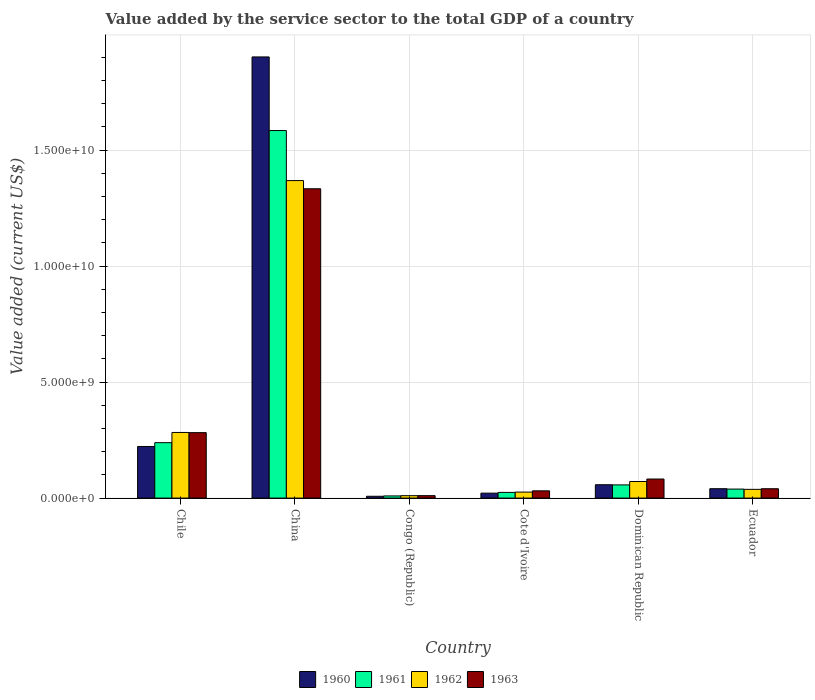How many different coloured bars are there?
Your answer should be very brief. 4. Are the number of bars per tick equal to the number of legend labels?
Offer a very short reply. Yes. How many bars are there on the 4th tick from the left?
Ensure brevity in your answer.  4. What is the label of the 5th group of bars from the left?
Keep it short and to the point. Dominican Republic. What is the value added by the service sector to the total GDP in 1960 in Chile?
Make the answer very short. 2.22e+09. Across all countries, what is the maximum value added by the service sector to the total GDP in 1963?
Make the answer very short. 1.33e+1. Across all countries, what is the minimum value added by the service sector to the total GDP in 1962?
Ensure brevity in your answer.  1.04e+08. In which country was the value added by the service sector to the total GDP in 1960 minimum?
Keep it short and to the point. Congo (Republic). What is the total value added by the service sector to the total GDP in 1961 in the graph?
Keep it short and to the point. 1.95e+1. What is the difference between the value added by the service sector to the total GDP in 1960 in Chile and that in Cote d'Ivoire?
Offer a very short reply. 2.01e+09. What is the difference between the value added by the service sector to the total GDP in 1962 in Chile and the value added by the service sector to the total GDP in 1960 in Dominican Republic?
Keep it short and to the point. 2.25e+09. What is the average value added by the service sector to the total GDP in 1963 per country?
Make the answer very short. 2.97e+09. What is the difference between the value added by the service sector to the total GDP of/in 1961 and value added by the service sector to the total GDP of/in 1963 in China?
Your response must be concise. 2.51e+09. In how many countries, is the value added by the service sector to the total GDP in 1961 greater than 11000000000 US$?
Provide a succinct answer. 1. What is the ratio of the value added by the service sector to the total GDP in 1961 in Cote d'Ivoire to that in Ecuador?
Make the answer very short. 0.63. Is the difference between the value added by the service sector to the total GDP in 1961 in Dominican Republic and Ecuador greater than the difference between the value added by the service sector to the total GDP in 1963 in Dominican Republic and Ecuador?
Your answer should be very brief. No. What is the difference between the highest and the second highest value added by the service sector to the total GDP in 1961?
Keep it short and to the point. 1.82e+09. What is the difference between the highest and the lowest value added by the service sector to the total GDP in 1963?
Keep it short and to the point. 1.32e+1. In how many countries, is the value added by the service sector to the total GDP in 1960 greater than the average value added by the service sector to the total GDP in 1960 taken over all countries?
Provide a short and direct response. 1. Is the sum of the value added by the service sector to the total GDP in 1963 in China and Cote d'Ivoire greater than the maximum value added by the service sector to the total GDP in 1960 across all countries?
Offer a very short reply. No. Is it the case that in every country, the sum of the value added by the service sector to the total GDP in 1962 and value added by the service sector to the total GDP in 1963 is greater than the sum of value added by the service sector to the total GDP in 1960 and value added by the service sector to the total GDP in 1961?
Offer a very short reply. No. How many bars are there?
Give a very brief answer. 24. What is the difference between two consecutive major ticks on the Y-axis?
Make the answer very short. 5.00e+09. Are the values on the major ticks of Y-axis written in scientific E-notation?
Keep it short and to the point. Yes. Does the graph contain any zero values?
Provide a short and direct response. No. Does the graph contain grids?
Provide a short and direct response. Yes. Where does the legend appear in the graph?
Give a very brief answer. Bottom center. How many legend labels are there?
Ensure brevity in your answer.  4. How are the legend labels stacked?
Provide a succinct answer. Horizontal. What is the title of the graph?
Your response must be concise. Value added by the service sector to the total GDP of a country. What is the label or title of the Y-axis?
Give a very brief answer. Value added (current US$). What is the Value added (current US$) of 1960 in Chile?
Ensure brevity in your answer.  2.22e+09. What is the Value added (current US$) of 1961 in Chile?
Provide a succinct answer. 2.39e+09. What is the Value added (current US$) of 1962 in Chile?
Provide a short and direct response. 2.83e+09. What is the Value added (current US$) in 1963 in Chile?
Provide a short and direct response. 2.82e+09. What is the Value added (current US$) of 1960 in China?
Provide a succinct answer. 1.90e+1. What is the Value added (current US$) of 1961 in China?
Make the answer very short. 1.58e+1. What is the Value added (current US$) of 1962 in China?
Your response must be concise. 1.37e+1. What is the Value added (current US$) in 1963 in China?
Provide a short and direct response. 1.33e+1. What is the Value added (current US$) in 1960 in Congo (Republic)?
Offer a very short reply. 7.82e+07. What is the Value added (current US$) in 1961 in Congo (Republic)?
Your answer should be compact. 9.33e+07. What is the Value added (current US$) of 1962 in Congo (Republic)?
Offer a very short reply. 1.04e+08. What is the Value added (current US$) of 1963 in Congo (Republic)?
Make the answer very short. 1.06e+08. What is the Value added (current US$) in 1960 in Cote d'Ivoire?
Provide a succinct answer. 2.13e+08. What is the Value added (current US$) of 1961 in Cote d'Ivoire?
Offer a terse response. 2.46e+08. What is the Value added (current US$) in 1962 in Cote d'Ivoire?
Provide a succinct answer. 2.59e+08. What is the Value added (current US$) of 1963 in Cote d'Ivoire?
Provide a short and direct response. 3.13e+08. What is the Value added (current US$) in 1960 in Dominican Republic?
Your response must be concise. 5.76e+08. What is the Value added (current US$) of 1961 in Dominican Republic?
Offer a very short reply. 5.68e+08. What is the Value added (current US$) in 1962 in Dominican Republic?
Provide a short and direct response. 7.14e+08. What is the Value added (current US$) in 1963 in Dominican Republic?
Your answer should be compact. 8.22e+08. What is the Value added (current US$) of 1960 in Ecuador?
Ensure brevity in your answer.  4.05e+08. What is the Value added (current US$) in 1961 in Ecuador?
Make the answer very short. 3.88e+08. What is the Value added (current US$) in 1962 in Ecuador?
Keep it short and to the point. 3.77e+08. What is the Value added (current US$) in 1963 in Ecuador?
Your answer should be very brief. 4.03e+08. Across all countries, what is the maximum Value added (current US$) in 1960?
Provide a succinct answer. 1.90e+1. Across all countries, what is the maximum Value added (current US$) of 1961?
Your answer should be compact. 1.58e+1. Across all countries, what is the maximum Value added (current US$) of 1962?
Ensure brevity in your answer.  1.37e+1. Across all countries, what is the maximum Value added (current US$) of 1963?
Your response must be concise. 1.33e+1. Across all countries, what is the minimum Value added (current US$) of 1960?
Provide a succinct answer. 7.82e+07. Across all countries, what is the minimum Value added (current US$) of 1961?
Keep it short and to the point. 9.33e+07. Across all countries, what is the minimum Value added (current US$) of 1962?
Your response must be concise. 1.04e+08. Across all countries, what is the minimum Value added (current US$) in 1963?
Give a very brief answer. 1.06e+08. What is the total Value added (current US$) of 1960 in the graph?
Your answer should be very brief. 2.25e+1. What is the total Value added (current US$) in 1961 in the graph?
Ensure brevity in your answer.  1.95e+1. What is the total Value added (current US$) in 1962 in the graph?
Give a very brief answer. 1.80e+1. What is the total Value added (current US$) of 1963 in the graph?
Make the answer very short. 1.78e+1. What is the difference between the Value added (current US$) in 1960 in Chile and that in China?
Offer a terse response. -1.68e+1. What is the difference between the Value added (current US$) in 1961 in Chile and that in China?
Your answer should be compact. -1.35e+1. What is the difference between the Value added (current US$) in 1962 in Chile and that in China?
Your response must be concise. -1.09e+1. What is the difference between the Value added (current US$) in 1963 in Chile and that in China?
Keep it short and to the point. -1.05e+1. What is the difference between the Value added (current US$) of 1960 in Chile and that in Congo (Republic)?
Give a very brief answer. 2.15e+09. What is the difference between the Value added (current US$) of 1961 in Chile and that in Congo (Republic)?
Offer a terse response. 2.30e+09. What is the difference between the Value added (current US$) in 1962 in Chile and that in Congo (Republic)?
Provide a succinct answer. 2.73e+09. What is the difference between the Value added (current US$) of 1963 in Chile and that in Congo (Republic)?
Make the answer very short. 2.72e+09. What is the difference between the Value added (current US$) in 1960 in Chile and that in Cote d'Ivoire?
Provide a short and direct response. 2.01e+09. What is the difference between the Value added (current US$) of 1961 in Chile and that in Cote d'Ivoire?
Your answer should be very brief. 2.14e+09. What is the difference between the Value added (current US$) in 1962 in Chile and that in Cote d'Ivoire?
Ensure brevity in your answer.  2.57e+09. What is the difference between the Value added (current US$) in 1963 in Chile and that in Cote d'Ivoire?
Your response must be concise. 2.51e+09. What is the difference between the Value added (current US$) of 1960 in Chile and that in Dominican Republic?
Your response must be concise. 1.65e+09. What is the difference between the Value added (current US$) of 1961 in Chile and that in Dominican Republic?
Offer a very short reply. 1.82e+09. What is the difference between the Value added (current US$) of 1962 in Chile and that in Dominican Republic?
Offer a terse response. 2.11e+09. What is the difference between the Value added (current US$) in 1963 in Chile and that in Dominican Republic?
Give a very brief answer. 2.00e+09. What is the difference between the Value added (current US$) of 1960 in Chile and that in Ecuador?
Keep it short and to the point. 1.82e+09. What is the difference between the Value added (current US$) of 1961 in Chile and that in Ecuador?
Your answer should be compact. 2.00e+09. What is the difference between the Value added (current US$) in 1962 in Chile and that in Ecuador?
Offer a terse response. 2.45e+09. What is the difference between the Value added (current US$) of 1963 in Chile and that in Ecuador?
Provide a succinct answer. 2.42e+09. What is the difference between the Value added (current US$) of 1960 in China and that in Congo (Republic)?
Keep it short and to the point. 1.89e+1. What is the difference between the Value added (current US$) in 1961 in China and that in Congo (Republic)?
Your answer should be very brief. 1.57e+1. What is the difference between the Value added (current US$) in 1962 in China and that in Congo (Republic)?
Your response must be concise. 1.36e+1. What is the difference between the Value added (current US$) in 1963 in China and that in Congo (Republic)?
Give a very brief answer. 1.32e+1. What is the difference between the Value added (current US$) in 1960 in China and that in Cote d'Ivoire?
Give a very brief answer. 1.88e+1. What is the difference between the Value added (current US$) in 1961 in China and that in Cote d'Ivoire?
Make the answer very short. 1.56e+1. What is the difference between the Value added (current US$) in 1962 in China and that in Cote d'Ivoire?
Your answer should be very brief. 1.34e+1. What is the difference between the Value added (current US$) of 1963 in China and that in Cote d'Ivoire?
Keep it short and to the point. 1.30e+1. What is the difference between the Value added (current US$) of 1960 in China and that in Dominican Republic?
Offer a very short reply. 1.84e+1. What is the difference between the Value added (current US$) in 1961 in China and that in Dominican Republic?
Keep it short and to the point. 1.53e+1. What is the difference between the Value added (current US$) of 1962 in China and that in Dominican Republic?
Your response must be concise. 1.30e+1. What is the difference between the Value added (current US$) of 1963 in China and that in Dominican Republic?
Make the answer very short. 1.25e+1. What is the difference between the Value added (current US$) of 1960 in China and that in Ecuador?
Your response must be concise. 1.86e+1. What is the difference between the Value added (current US$) in 1961 in China and that in Ecuador?
Offer a terse response. 1.55e+1. What is the difference between the Value added (current US$) of 1962 in China and that in Ecuador?
Keep it short and to the point. 1.33e+1. What is the difference between the Value added (current US$) of 1963 in China and that in Ecuador?
Make the answer very short. 1.29e+1. What is the difference between the Value added (current US$) of 1960 in Congo (Republic) and that in Cote d'Ivoire?
Your answer should be very brief. -1.35e+08. What is the difference between the Value added (current US$) in 1961 in Congo (Republic) and that in Cote d'Ivoire?
Keep it short and to the point. -1.52e+08. What is the difference between the Value added (current US$) in 1962 in Congo (Republic) and that in Cote d'Ivoire?
Your answer should be compact. -1.55e+08. What is the difference between the Value added (current US$) of 1963 in Congo (Republic) and that in Cote d'Ivoire?
Provide a succinct answer. -2.08e+08. What is the difference between the Value added (current US$) in 1960 in Congo (Republic) and that in Dominican Republic?
Your answer should be very brief. -4.98e+08. What is the difference between the Value added (current US$) of 1961 in Congo (Republic) and that in Dominican Republic?
Provide a succinct answer. -4.75e+08. What is the difference between the Value added (current US$) of 1962 in Congo (Republic) and that in Dominican Republic?
Keep it short and to the point. -6.11e+08. What is the difference between the Value added (current US$) of 1963 in Congo (Republic) and that in Dominican Republic?
Provide a succinct answer. -7.16e+08. What is the difference between the Value added (current US$) in 1960 in Congo (Republic) and that in Ecuador?
Provide a succinct answer. -3.27e+08. What is the difference between the Value added (current US$) in 1961 in Congo (Republic) and that in Ecuador?
Provide a succinct answer. -2.95e+08. What is the difference between the Value added (current US$) in 1962 in Congo (Republic) and that in Ecuador?
Keep it short and to the point. -2.73e+08. What is the difference between the Value added (current US$) in 1963 in Congo (Republic) and that in Ecuador?
Ensure brevity in your answer.  -2.98e+08. What is the difference between the Value added (current US$) in 1960 in Cote d'Ivoire and that in Dominican Republic?
Your answer should be compact. -3.63e+08. What is the difference between the Value added (current US$) in 1961 in Cote d'Ivoire and that in Dominican Republic?
Give a very brief answer. -3.23e+08. What is the difference between the Value added (current US$) of 1962 in Cote d'Ivoire and that in Dominican Republic?
Your response must be concise. -4.56e+08. What is the difference between the Value added (current US$) of 1963 in Cote d'Ivoire and that in Dominican Republic?
Your response must be concise. -5.09e+08. What is the difference between the Value added (current US$) of 1960 in Cote d'Ivoire and that in Ecuador?
Ensure brevity in your answer.  -1.92e+08. What is the difference between the Value added (current US$) in 1961 in Cote d'Ivoire and that in Ecuador?
Your answer should be very brief. -1.42e+08. What is the difference between the Value added (current US$) in 1962 in Cote d'Ivoire and that in Ecuador?
Your response must be concise. -1.18e+08. What is the difference between the Value added (current US$) of 1963 in Cote d'Ivoire and that in Ecuador?
Ensure brevity in your answer.  -9.04e+07. What is the difference between the Value added (current US$) in 1960 in Dominican Republic and that in Ecuador?
Offer a very short reply. 1.71e+08. What is the difference between the Value added (current US$) in 1961 in Dominican Republic and that in Ecuador?
Your answer should be compact. 1.81e+08. What is the difference between the Value added (current US$) of 1962 in Dominican Republic and that in Ecuador?
Keep it short and to the point. 3.38e+08. What is the difference between the Value added (current US$) of 1963 in Dominican Republic and that in Ecuador?
Give a very brief answer. 4.18e+08. What is the difference between the Value added (current US$) in 1960 in Chile and the Value added (current US$) in 1961 in China?
Your answer should be very brief. -1.36e+1. What is the difference between the Value added (current US$) in 1960 in Chile and the Value added (current US$) in 1962 in China?
Make the answer very short. -1.15e+1. What is the difference between the Value added (current US$) of 1960 in Chile and the Value added (current US$) of 1963 in China?
Give a very brief answer. -1.11e+1. What is the difference between the Value added (current US$) of 1961 in Chile and the Value added (current US$) of 1962 in China?
Your response must be concise. -1.13e+1. What is the difference between the Value added (current US$) of 1961 in Chile and the Value added (current US$) of 1963 in China?
Ensure brevity in your answer.  -1.09e+1. What is the difference between the Value added (current US$) in 1962 in Chile and the Value added (current US$) in 1963 in China?
Your answer should be very brief. -1.05e+1. What is the difference between the Value added (current US$) in 1960 in Chile and the Value added (current US$) in 1961 in Congo (Republic)?
Make the answer very short. 2.13e+09. What is the difference between the Value added (current US$) of 1960 in Chile and the Value added (current US$) of 1962 in Congo (Republic)?
Your answer should be very brief. 2.12e+09. What is the difference between the Value added (current US$) in 1960 in Chile and the Value added (current US$) in 1963 in Congo (Republic)?
Make the answer very short. 2.12e+09. What is the difference between the Value added (current US$) in 1961 in Chile and the Value added (current US$) in 1962 in Congo (Republic)?
Offer a very short reply. 2.29e+09. What is the difference between the Value added (current US$) in 1961 in Chile and the Value added (current US$) in 1963 in Congo (Republic)?
Your answer should be compact. 2.28e+09. What is the difference between the Value added (current US$) of 1962 in Chile and the Value added (current US$) of 1963 in Congo (Republic)?
Offer a very short reply. 2.72e+09. What is the difference between the Value added (current US$) of 1960 in Chile and the Value added (current US$) of 1961 in Cote d'Ivoire?
Your answer should be very brief. 1.98e+09. What is the difference between the Value added (current US$) in 1960 in Chile and the Value added (current US$) in 1962 in Cote d'Ivoire?
Make the answer very short. 1.97e+09. What is the difference between the Value added (current US$) of 1960 in Chile and the Value added (current US$) of 1963 in Cote d'Ivoire?
Keep it short and to the point. 1.91e+09. What is the difference between the Value added (current US$) in 1961 in Chile and the Value added (current US$) in 1962 in Cote d'Ivoire?
Offer a terse response. 2.13e+09. What is the difference between the Value added (current US$) of 1961 in Chile and the Value added (current US$) of 1963 in Cote d'Ivoire?
Provide a succinct answer. 2.08e+09. What is the difference between the Value added (current US$) of 1962 in Chile and the Value added (current US$) of 1963 in Cote d'Ivoire?
Keep it short and to the point. 2.52e+09. What is the difference between the Value added (current US$) in 1960 in Chile and the Value added (current US$) in 1961 in Dominican Republic?
Give a very brief answer. 1.66e+09. What is the difference between the Value added (current US$) in 1960 in Chile and the Value added (current US$) in 1962 in Dominican Republic?
Ensure brevity in your answer.  1.51e+09. What is the difference between the Value added (current US$) in 1960 in Chile and the Value added (current US$) in 1963 in Dominican Republic?
Provide a succinct answer. 1.40e+09. What is the difference between the Value added (current US$) of 1961 in Chile and the Value added (current US$) of 1962 in Dominican Republic?
Provide a short and direct response. 1.67e+09. What is the difference between the Value added (current US$) of 1961 in Chile and the Value added (current US$) of 1963 in Dominican Republic?
Offer a terse response. 1.57e+09. What is the difference between the Value added (current US$) in 1962 in Chile and the Value added (current US$) in 1963 in Dominican Republic?
Offer a very short reply. 2.01e+09. What is the difference between the Value added (current US$) in 1960 in Chile and the Value added (current US$) in 1961 in Ecuador?
Make the answer very short. 1.84e+09. What is the difference between the Value added (current US$) of 1960 in Chile and the Value added (current US$) of 1962 in Ecuador?
Give a very brief answer. 1.85e+09. What is the difference between the Value added (current US$) in 1960 in Chile and the Value added (current US$) in 1963 in Ecuador?
Keep it short and to the point. 1.82e+09. What is the difference between the Value added (current US$) in 1961 in Chile and the Value added (current US$) in 1962 in Ecuador?
Give a very brief answer. 2.01e+09. What is the difference between the Value added (current US$) of 1961 in Chile and the Value added (current US$) of 1963 in Ecuador?
Make the answer very short. 1.99e+09. What is the difference between the Value added (current US$) of 1962 in Chile and the Value added (current US$) of 1963 in Ecuador?
Keep it short and to the point. 2.43e+09. What is the difference between the Value added (current US$) in 1960 in China and the Value added (current US$) in 1961 in Congo (Republic)?
Your answer should be compact. 1.89e+1. What is the difference between the Value added (current US$) in 1960 in China and the Value added (current US$) in 1962 in Congo (Republic)?
Give a very brief answer. 1.89e+1. What is the difference between the Value added (current US$) of 1960 in China and the Value added (current US$) of 1963 in Congo (Republic)?
Your answer should be very brief. 1.89e+1. What is the difference between the Value added (current US$) of 1961 in China and the Value added (current US$) of 1962 in Congo (Republic)?
Your answer should be very brief. 1.57e+1. What is the difference between the Value added (current US$) of 1961 in China and the Value added (current US$) of 1963 in Congo (Republic)?
Your answer should be very brief. 1.57e+1. What is the difference between the Value added (current US$) in 1962 in China and the Value added (current US$) in 1963 in Congo (Republic)?
Give a very brief answer. 1.36e+1. What is the difference between the Value added (current US$) in 1960 in China and the Value added (current US$) in 1961 in Cote d'Ivoire?
Your response must be concise. 1.88e+1. What is the difference between the Value added (current US$) in 1960 in China and the Value added (current US$) in 1962 in Cote d'Ivoire?
Your answer should be very brief. 1.88e+1. What is the difference between the Value added (current US$) of 1960 in China and the Value added (current US$) of 1963 in Cote d'Ivoire?
Ensure brevity in your answer.  1.87e+1. What is the difference between the Value added (current US$) in 1961 in China and the Value added (current US$) in 1962 in Cote d'Ivoire?
Your answer should be very brief. 1.56e+1. What is the difference between the Value added (current US$) of 1961 in China and the Value added (current US$) of 1963 in Cote d'Ivoire?
Your answer should be very brief. 1.55e+1. What is the difference between the Value added (current US$) of 1962 in China and the Value added (current US$) of 1963 in Cote d'Ivoire?
Your response must be concise. 1.34e+1. What is the difference between the Value added (current US$) of 1960 in China and the Value added (current US$) of 1961 in Dominican Republic?
Provide a succinct answer. 1.84e+1. What is the difference between the Value added (current US$) in 1960 in China and the Value added (current US$) in 1962 in Dominican Republic?
Your answer should be compact. 1.83e+1. What is the difference between the Value added (current US$) in 1960 in China and the Value added (current US$) in 1963 in Dominican Republic?
Your answer should be very brief. 1.82e+1. What is the difference between the Value added (current US$) of 1961 in China and the Value added (current US$) of 1962 in Dominican Republic?
Offer a terse response. 1.51e+1. What is the difference between the Value added (current US$) of 1961 in China and the Value added (current US$) of 1963 in Dominican Republic?
Your response must be concise. 1.50e+1. What is the difference between the Value added (current US$) of 1962 in China and the Value added (current US$) of 1963 in Dominican Republic?
Keep it short and to the point. 1.29e+1. What is the difference between the Value added (current US$) of 1960 in China and the Value added (current US$) of 1961 in Ecuador?
Your response must be concise. 1.86e+1. What is the difference between the Value added (current US$) of 1960 in China and the Value added (current US$) of 1962 in Ecuador?
Your response must be concise. 1.86e+1. What is the difference between the Value added (current US$) of 1960 in China and the Value added (current US$) of 1963 in Ecuador?
Offer a very short reply. 1.86e+1. What is the difference between the Value added (current US$) of 1961 in China and the Value added (current US$) of 1962 in Ecuador?
Offer a very short reply. 1.55e+1. What is the difference between the Value added (current US$) in 1961 in China and the Value added (current US$) in 1963 in Ecuador?
Your response must be concise. 1.54e+1. What is the difference between the Value added (current US$) of 1962 in China and the Value added (current US$) of 1963 in Ecuador?
Keep it short and to the point. 1.33e+1. What is the difference between the Value added (current US$) of 1960 in Congo (Republic) and the Value added (current US$) of 1961 in Cote d'Ivoire?
Your answer should be compact. -1.67e+08. What is the difference between the Value added (current US$) in 1960 in Congo (Republic) and the Value added (current US$) in 1962 in Cote d'Ivoire?
Provide a succinct answer. -1.81e+08. What is the difference between the Value added (current US$) of 1960 in Congo (Republic) and the Value added (current US$) of 1963 in Cote d'Ivoire?
Make the answer very short. -2.35e+08. What is the difference between the Value added (current US$) in 1961 in Congo (Republic) and the Value added (current US$) in 1962 in Cote d'Ivoire?
Your response must be concise. -1.66e+08. What is the difference between the Value added (current US$) in 1961 in Congo (Republic) and the Value added (current US$) in 1963 in Cote d'Ivoire?
Give a very brief answer. -2.20e+08. What is the difference between the Value added (current US$) of 1962 in Congo (Republic) and the Value added (current US$) of 1963 in Cote d'Ivoire?
Offer a very short reply. -2.09e+08. What is the difference between the Value added (current US$) in 1960 in Congo (Republic) and the Value added (current US$) in 1961 in Dominican Republic?
Ensure brevity in your answer.  -4.90e+08. What is the difference between the Value added (current US$) of 1960 in Congo (Republic) and the Value added (current US$) of 1962 in Dominican Republic?
Your response must be concise. -6.36e+08. What is the difference between the Value added (current US$) in 1960 in Congo (Republic) and the Value added (current US$) in 1963 in Dominican Republic?
Keep it short and to the point. -7.43e+08. What is the difference between the Value added (current US$) in 1961 in Congo (Republic) and the Value added (current US$) in 1962 in Dominican Republic?
Keep it short and to the point. -6.21e+08. What is the difference between the Value added (current US$) in 1961 in Congo (Republic) and the Value added (current US$) in 1963 in Dominican Republic?
Make the answer very short. -7.28e+08. What is the difference between the Value added (current US$) in 1962 in Congo (Republic) and the Value added (current US$) in 1963 in Dominican Republic?
Provide a succinct answer. -7.18e+08. What is the difference between the Value added (current US$) of 1960 in Congo (Republic) and the Value added (current US$) of 1961 in Ecuador?
Offer a very short reply. -3.10e+08. What is the difference between the Value added (current US$) in 1960 in Congo (Republic) and the Value added (current US$) in 1962 in Ecuador?
Your response must be concise. -2.99e+08. What is the difference between the Value added (current US$) of 1960 in Congo (Republic) and the Value added (current US$) of 1963 in Ecuador?
Offer a very short reply. -3.25e+08. What is the difference between the Value added (current US$) in 1961 in Congo (Republic) and the Value added (current US$) in 1962 in Ecuador?
Offer a very short reply. -2.84e+08. What is the difference between the Value added (current US$) of 1961 in Congo (Republic) and the Value added (current US$) of 1963 in Ecuador?
Your answer should be very brief. -3.10e+08. What is the difference between the Value added (current US$) of 1962 in Congo (Republic) and the Value added (current US$) of 1963 in Ecuador?
Make the answer very short. -3.00e+08. What is the difference between the Value added (current US$) in 1960 in Cote d'Ivoire and the Value added (current US$) in 1961 in Dominican Republic?
Give a very brief answer. -3.56e+08. What is the difference between the Value added (current US$) in 1960 in Cote d'Ivoire and the Value added (current US$) in 1962 in Dominican Republic?
Keep it short and to the point. -5.02e+08. What is the difference between the Value added (current US$) in 1960 in Cote d'Ivoire and the Value added (current US$) in 1963 in Dominican Republic?
Offer a terse response. -6.09e+08. What is the difference between the Value added (current US$) of 1961 in Cote d'Ivoire and the Value added (current US$) of 1962 in Dominican Republic?
Make the answer very short. -4.69e+08. What is the difference between the Value added (current US$) of 1961 in Cote d'Ivoire and the Value added (current US$) of 1963 in Dominican Republic?
Provide a short and direct response. -5.76e+08. What is the difference between the Value added (current US$) of 1962 in Cote d'Ivoire and the Value added (current US$) of 1963 in Dominican Republic?
Make the answer very short. -5.63e+08. What is the difference between the Value added (current US$) in 1960 in Cote d'Ivoire and the Value added (current US$) in 1961 in Ecuador?
Offer a very short reply. -1.75e+08. What is the difference between the Value added (current US$) of 1960 in Cote d'Ivoire and the Value added (current US$) of 1962 in Ecuador?
Your answer should be compact. -1.64e+08. What is the difference between the Value added (current US$) in 1960 in Cote d'Ivoire and the Value added (current US$) in 1963 in Ecuador?
Your response must be concise. -1.91e+08. What is the difference between the Value added (current US$) in 1961 in Cote d'Ivoire and the Value added (current US$) in 1962 in Ecuador?
Your answer should be compact. -1.31e+08. What is the difference between the Value added (current US$) of 1961 in Cote d'Ivoire and the Value added (current US$) of 1963 in Ecuador?
Your answer should be very brief. -1.58e+08. What is the difference between the Value added (current US$) in 1962 in Cote d'Ivoire and the Value added (current US$) in 1963 in Ecuador?
Keep it short and to the point. -1.45e+08. What is the difference between the Value added (current US$) in 1960 in Dominican Republic and the Value added (current US$) in 1961 in Ecuador?
Your answer should be very brief. 1.88e+08. What is the difference between the Value added (current US$) of 1960 in Dominican Republic and the Value added (current US$) of 1962 in Ecuador?
Your answer should be compact. 1.99e+08. What is the difference between the Value added (current US$) of 1960 in Dominican Republic and the Value added (current US$) of 1963 in Ecuador?
Provide a succinct answer. 1.73e+08. What is the difference between the Value added (current US$) of 1961 in Dominican Republic and the Value added (current US$) of 1962 in Ecuador?
Ensure brevity in your answer.  1.92e+08. What is the difference between the Value added (current US$) of 1961 in Dominican Republic and the Value added (current US$) of 1963 in Ecuador?
Your response must be concise. 1.65e+08. What is the difference between the Value added (current US$) in 1962 in Dominican Republic and the Value added (current US$) in 1963 in Ecuador?
Make the answer very short. 3.11e+08. What is the average Value added (current US$) of 1960 per country?
Keep it short and to the point. 3.75e+09. What is the average Value added (current US$) of 1961 per country?
Offer a very short reply. 3.25e+09. What is the average Value added (current US$) in 1962 per country?
Make the answer very short. 2.99e+09. What is the average Value added (current US$) in 1963 per country?
Give a very brief answer. 2.97e+09. What is the difference between the Value added (current US$) of 1960 and Value added (current US$) of 1961 in Chile?
Offer a terse response. -1.64e+08. What is the difference between the Value added (current US$) of 1960 and Value added (current US$) of 1962 in Chile?
Your response must be concise. -6.04e+08. What is the difference between the Value added (current US$) in 1960 and Value added (current US$) in 1963 in Chile?
Your response must be concise. -5.96e+08. What is the difference between the Value added (current US$) in 1961 and Value added (current US$) in 1962 in Chile?
Provide a succinct answer. -4.40e+08. What is the difference between the Value added (current US$) in 1961 and Value added (current US$) in 1963 in Chile?
Ensure brevity in your answer.  -4.32e+08. What is the difference between the Value added (current US$) in 1962 and Value added (current US$) in 1963 in Chile?
Ensure brevity in your answer.  8.01e+06. What is the difference between the Value added (current US$) of 1960 and Value added (current US$) of 1961 in China?
Offer a very short reply. 3.17e+09. What is the difference between the Value added (current US$) of 1960 and Value added (current US$) of 1962 in China?
Ensure brevity in your answer.  5.33e+09. What is the difference between the Value added (current US$) in 1960 and Value added (current US$) in 1963 in China?
Provide a short and direct response. 5.68e+09. What is the difference between the Value added (current US$) of 1961 and Value added (current US$) of 1962 in China?
Offer a terse response. 2.16e+09. What is the difference between the Value added (current US$) of 1961 and Value added (current US$) of 1963 in China?
Provide a short and direct response. 2.51e+09. What is the difference between the Value added (current US$) of 1962 and Value added (current US$) of 1963 in China?
Make the answer very short. 3.53e+08. What is the difference between the Value added (current US$) of 1960 and Value added (current US$) of 1961 in Congo (Republic)?
Give a very brief answer. -1.51e+07. What is the difference between the Value added (current US$) of 1960 and Value added (current US$) of 1962 in Congo (Republic)?
Make the answer very short. -2.55e+07. What is the difference between the Value added (current US$) in 1960 and Value added (current US$) in 1963 in Congo (Republic)?
Provide a short and direct response. -2.73e+07. What is the difference between the Value added (current US$) of 1961 and Value added (current US$) of 1962 in Congo (Republic)?
Offer a terse response. -1.05e+07. What is the difference between the Value added (current US$) in 1961 and Value added (current US$) in 1963 in Congo (Republic)?
Give a very brief answer. -1.23e+07. What is the difference between the Value added (current US$) of 1962 and Value added (current US$) of 1963 in Congo (Republic)?
Make the answer very short. -1.79e+06. What is the difference between the Value added (current US$) in 1960 and Value added (current US$) in 1961 in Cote d'Ivoire?
Ensure brevity in your answer.  -3.28e+07. What is the difference between the Value added (current US$) of 1960 and Value added (current US$) of 1962 in Cote d'Ivoire?
Offer a very short reply. -4.61e+07. What is the difference between the Value added (current US$) in 1960 and Value added (current US$) in 1963 in Cote d'Ivoire?
Your answer should be very brief. -1.00e+08. What is the difference between the Value added (current US$) in 1961 and Value added (current US$) in 1962 in Cote d'Ivoire?
Your answer should be compact. -1.33e+07. What is the difference between the Value added (current US$) in 1961 and Value added (current US$) in 1963 in Cote d'Ivoire?
Give a very brief answer. -6.75e+07. What is the difference between the Value added (current US$) of 1962 and Value added (current US$) of 1963 in Cote d'Ivoire?
Provide a short and direct response. -5.42e+07. What is the difference between the Value added (current US$) in 1960 and Value added (current US$) in 1961 in Dominican Republic?
Offer a terse response. 7.50e+06. What is the difference between the Value added (current US$) in 1960 and Value added (current US$) in 1962 in Dominican Republic?
Your answer should be compact. -1.39e+08. What is the difference between the Value added (current US$) in 1960 and Value added (current US$) in 1963 in Dominican Republic?
Ensure brevity in your answer.  -2.46e+08. What is the difference between the Value added (current US$) in 1961 and Value added (current US$) in 1962 in Dominican Republic?
Your answer should be very brief. -1.46e+08. What is the difference between the Value added (current US$) of 1961 and Value added (current US$) of 1963 in Dominican Republic?
Your response must be concise. -2.53e+08. What is the difference between the Value added (current US$) of 1962 and Value added (current US$) of 1963 in Dominican Republic?
Give a very brief answer. -1.07e+08. What is the difference between the Value added (current US$) in 1960 and Value added (current US$) in 1961 in Ecuador?
Your answer should be compact. 1.69e+07. What is the difference between the Value added (current US$) of 1960 and Value added (current US$) of 1962 in Ecuador?
Your response must be concise. 2.79e+07. What is the difference between the Value added (current US$) in 1960 and Value added (current US$) in 1963 in Ecuador?
Your answer should be very brief. 1.47e+06. What is the difference between the Value added (current US$) in 1961 and Value added (current US$) in 1962 in Ecuador?
Offer a terse response. 1.10e+07. What is the difference between the Value added (current US$) in 1961 and Value added (current US$) in 1963 in Ecuador?
Your answer should be compact. -1.54e+07. What is the difference between the Value added (current US$) of 1962 and Value added (current US$) of 1963 in Ecuador?
Keep it short and to the point. -2.64e+07. What is the ratio of the Value added (current US$) in 1960 in Chile to that in China?
Your response must be concise. 0.12. What is the ratio of the Value added (current US$) in 1961 in Chile to that in China?
Your response must be concise. 0.15. What is the ratio of the Value added (current US$) of 1962 in Chile to that in China?
Your answer should be compact. 0.21. What is the ratio of the Value added (current US$) in 1963 in Chile to that in China?
Provide a succinct answer. 0.21. What is the ratio of the Value added (current US$) of 1960 in Chile to that in Congo (Republic)?
Give a very brief answer. 28.44. What is the ratio of the Value added (current US$) in 1961 in Chile to that in Congo (Republic)?
Provide a short and direct response. 25.61. What is the ratio of the Value added (current US$) of 1962 in Chile to that in Congo (Republic)?
Provide a short and direct response. 27.27. What is the ratio of the Value added (current US$) of 1963 in Chile to that in Congo (Republic)?
Provide a succinct answer. 26.73. What is the ratio of the Value added (current US$) of 1960 in Chile to that in Cote d'Ivoire?
Make the answer very short. 10.45. What is the ratio of the Value added (current US$) in 1961 in Chile to that in Cote d'Ivoire?
Ensure brevity in your answer.  9.73. What is the ratio of the Value added (current US$) in 1962 in Chile to that in Cote d'Ivoire?
Give a very brief answer. 10.93. What is the ratio of the Value added (current US$) of 1963 in Chile to that in Cote d'Ivoire?
Provide a short and direct response. 9.01. What is the ratio of the Value added (current US$) in 1960 in Chile to that in Dominican Republic?
Your answer should be very brief. 3.86. What is the ratio of the Value added (current US$) in 1961 in Chile to that in Dominican Republic?
Provide a short and direct response. 4.2. What is the ratio of the Value added (current US$) of 1962 in Chile to that in Dominican Republic?
Your answer should be compact. 3.96. What is the ratio of the Value added (current US$) in 1963 in Chile to that in Dominican Republic?
Ensure brevity in your answer.  3.43. What is the ratio of the Value added (current US$) of 1960 in Chile to that in Ecuador?
Give a very brief answer. 5.49. What is the ratio of the Value added (current US$) of 1961 in Chile to that in Ecuador?
Keep it short and to the point. 6.16. What is the ratio of the Value added (current US$) in 1962 in Chile to that in Ecuador?
Provide a short and direct response. 7.5. What is the ratio of the Value added (current US$) in 1963 in Chile to that in Ecuador?
Provide a succinct answer. 6.99. What is the ratio of the Value added (current US$) of 1960 in China to that in Congo (Republic)?
Offer a very short reply. 243.12. What is the ratio of the Value added (current US$) in 1961 in China to that in Congo (Republic)?
Give a very brief answer. 169.84. What is the ratio of the Value added (current US$) of 1962 in China to that in Congo (Republic)?
Keep it short and to the point. 131.91. What is the ratio of the Value added (current US$) of 1963 in China to that in Congo (Republic)?
Provide a short and direct response. 126.33. What is the ratio of the Value added (current US$) of 1960 in China to that in Cote d'Ivoire?
Provide a succinct answer. 89.37. What is the ratio of the Value added (current US$) in 1961 in China to that in Cote d'Ivoire?
Provide a succinct answer. 64.52. What is the ratio of the Value added (current US$) in 1962 in China to that in Cote d'Ivoire?
Your answer should be very brief. 52.87. What is the ratio of the Value added (current US$) in 1963 in China to that in Cote d'Ivoire?
Provide a short and direct response. 42.59. What is the ratio of the Value added (current US$) of 1960 in China to that in Dominican Republic?
Your response must be concise. 33.01. What is the ratio of the Value added (current US$) of 1961 in China to that in Dominican Republic?
Provide a short and direct response. 27.87. What is the ratio of the Value added (current US$) of 1962 in China to that in Dominican Republic?
Make the answer very short. 19.15. What is the ratio of the Value added (current US$) of 1963 in China to that in Dominican Republic?
Provide a succinct answer. 16.23. What is the ratio of the Value added (current US$) in 1960 in China to that in Ecuador?
Provide a succinct answer. 46.96. What is the ratio of the Value added (current US$) of 1961 in China to that in Ecuador?
Your response must be concise. 40.83. What is the ratio of the Value added (current US$) of 1962 in China to that in Ecuador?
Keep it short and to the point. 36.3. What is the ratio of the Value added (current US$) in 1963 in China to that in Ecuador?
Ensure brevity in your answer.  33.05. What is the ratio of the Value added (current US$) in 1960 in Congo (Republic) to that in Cote d'Ivoire?
Your answer should be compact. 0.37. What is the ratio of the Value added (current US$) in 1961 in Congo (Republic) to that in Cote d'Ivoire?
Provide a succinct answer. 0.38. What is the ratio of the Value added (current US$) in 1962 in Congo (Republic) to that in Cote d'Ivoire?
Keep it short and to the point. 0.4. What is the ratio of the Value added (current US$) in 1963 in Congo (Republic) to that in Cote d'Ivoire?
Provide a succinct answer. 0.34. What is the ratio of the Value added (current US$) of 1960 in Congo (Republic) to that in Dominican Republic?
Make the answer very short. 0.14. What is the ratio of the Value added (current US$) of 1961 in Congo (Republic) to that in Dominican Republic?
Your answer should be very brief. 0.16. What is the ratio of the Value added (current US$) in 1962 in Congo (Republic) to that in Dominican Republic?
Your answer should be very brief. 0.15. What is the ratio of the Value added (current US$) in 1963 in Congo (Republic) to that in Dominican Republic?
Ensure brevity in your answer.  0.13. What is the ratio of the Value added (current US$) of 1960 in Congo (Republic) to that in Ecuador?
Provide a short and direct response. 0.19. What is the ratio of the Value added (current US$) of 1961 in Congo (Republic) to that in Ecuador?
Your answer should be compact. 0.24. What is the ratio of the Value added (current US$) of 1962 in Congo (Republic) to that in Ecuador?
Your answer should be very brief. 0.28. What is the ratio of the Value added (current US$) in 1963 in Congo (Republic) to that in Ecuador?
Give a very brief answer. 0.26. What is the ratio of the Value added (current US$) in 1960 in Cote d'Ivoire to that in Dominican Republic?
Your response must be concise. 0.37. What is the ratio of the Value added (current US$) in 1961 in Cote d'Ivoire to that in Dominican Republic?
Provide a short and direct response. 0.43. What is the ratio of the Value added (current US$) in 1962 in Cote d'Ivoire to that in Dominican Republic?
Make the answer very short. 0.36. What is the ratio of the Value added (current US$) in 1963 in Cote d'Ivoire to that in Dominican Republic?
Keep it short and to the point. 0.38. What is the ratio of the Value added (current US$) in 1960 in Cote d'Ivoire to that in Ecuador?
Make the answer very short. 0.53. What is the ratio of the Value added (current US$) of 1961 in Cote d'Ivoire to that in Ecuador?
Keep it short and to the point. 0.63. What is the ratio of the Value added (current US$) in 1962 in Cote d'Ivoire to that in Ecuador?
Offer a terse response. 0.69. What is the ratio of the Value added (current US$) in 1963 in Cote d'Ivoire to that in Ecuador?
Provide a succinct answer. 0.78. What is the ratio of the Value added (current US$) of 1960 in Dominican Republic to that in Ecuador?
Provide a succinct answer. 1.42. What is the ratio of the Value added (current US$) of 1961 in Dominican Republic to that in Ecuador?
Provide a succinct answer. 1.47. What is the ratio of the Value added (current US$) of 1962 in Dominican Republic to that in Ecuador?
Offer a terse response. 1.9. What is the ratio of the Value added (current US$) of 1963 in Dominican Republic to that in Ecuador?
Provide a succinct answer. 2.04. What is the difference between the highest and the second highest Value added (current US$) of 1960?
Provide a short and direct response. 1.68e+1. What is the difference between the highest and the second highest Value added (current US$) in 1961?
Your answer should be compact. 1.35e+1. What is the difference between the highest and the second highest Value added (current US$) of 1962?
Your answer should be very brief. 1.09e+1. What is the difference between the highest and the second highest Value added (current US$) in 1963?
Make the answer very short. 1.05e+1. What is the difference between the highest and the lowest Value added (current US$) in 1960?
Your response must be concise. 1.89e+1. What is the difference between the highest and the lowest Value added (current US$) in 1961?
Your response must be concise. 1.57e+1. What is the difference between the highest and the lowest Value added (current US$) in 1962?
Ensure brevity in your answer.  1.36e+1. What is the difference between the highest and the lowest Value added (current US$) in 1963?
Provide a short and direct response. 1.32e+1. 